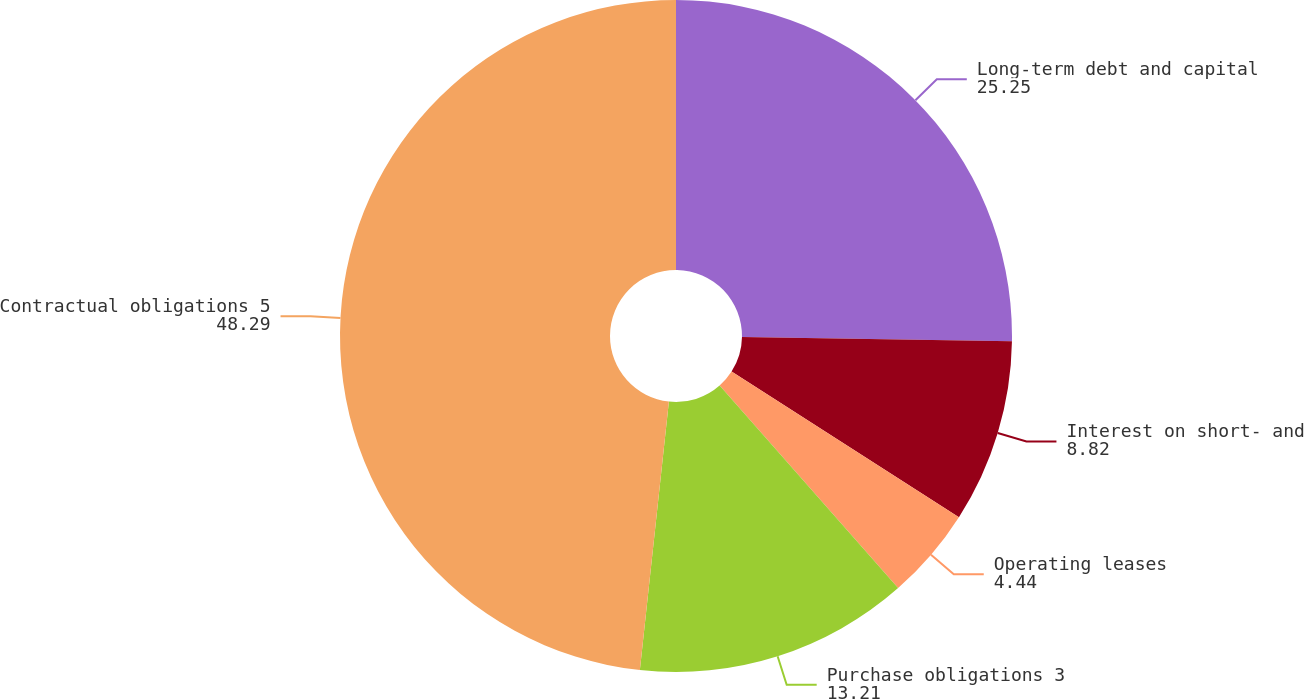Convert chart. <chart><loc_0><loc_0><loc_500><loc_500><pie_chart><fcel>Long-term debt and capital<fcel>Interest on short- and<fcel>Operating leases<fcel>Purchase obligations 3<fcel>Contractual obligations 5<nl><fcel>25.25%<fcel>8.82%<fcel>4.44%<fcel>13.21%<fcel>48.29%<nl></chart> 